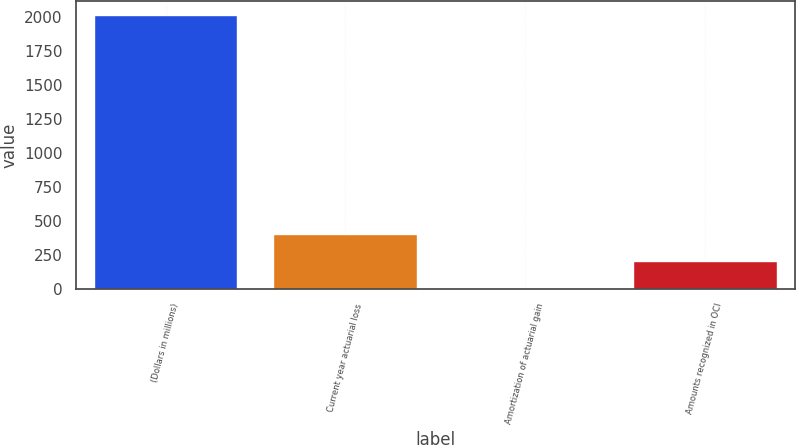<chart> <loc_0><loc_0><loc_500><loc_500><bar_chart><fcel>(Dollars in millions)<fcel>Current year actuarial loss<fcel>Amortization of actuarial gain<fcel>Amounts recognized in OCI<nl><fcel>2016<fcel>408<fcel>6<fcel>207<nl></chart> 